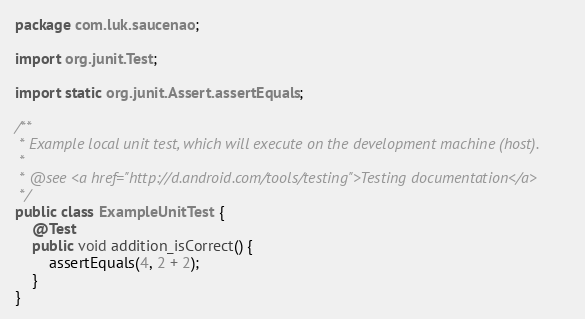<code> <loc_0><loc_0><loc_500><loc_500><_Java_>package com.luk.saucenao;

import org.junit.Test;

import static org.junit.Assert.assertEquals;

/**
 * Example local unit test, which will execute on the development machine (host).
 *
 * @see <a href="http://d.android.com/tools/testing">Testing documentation</a>
 */
public class ExampleUnitTest {
    @Test
    public void addition_isCorrect() {
        assertEquals(4, 2 + 2);
    }
}</code> 